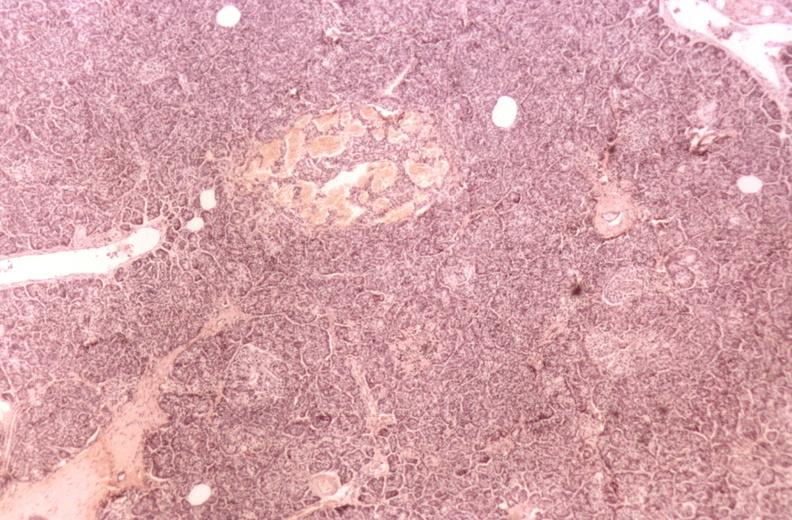what does this image show?
Answer the question using a single word or phrase. Kidney 